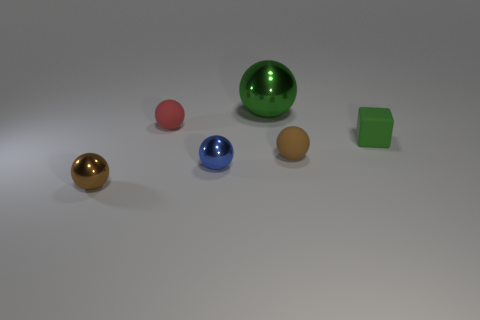How many other things are the same size as the green cube?
Make the answer very short. 4. What size is the other red matte thing that is the same shape as the big object?
Your answer should be compact. Small. What is the shape of the brown object right of the green shiny thing?
Provide a short and direct response. Sphere. What is the color of the sphere to the right of the shiny object that is behind the tiny block?
Keep it short and to the point. Brown. What number of things are either metal balls that are behind the small brown matte ball or green metallic balls?
Your answer should be compact. 1. There is a green sphere; is it the same size as the rubber sphere that is right of the small red rubber sphere?
Give a very brief answer. No. What number of large objects are green matte cubes or red balls?
Provide a short and direct response. 0. What is the shape of the brown metallic object?
Offer a terse response. Sphere. The rubber object that is the same color as the big ball is what size?
Provide a succinct answer. Small. Are there any tiny gray cylinders that have the same material as the tiny blue thing?
Keep it short and to the point. No. 